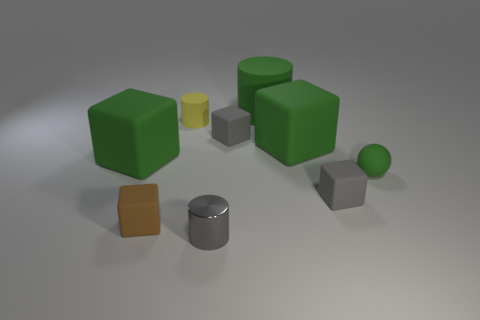Subtract all gray cubes. How many cubes are left? 3 Subtract all green blocks. How many blocks are left? 3 Add 1 rubber spheres. How many objects exist? 10 Subtract all cyan blocks. Subtract all red cylinders. How many blocks are left? 5 Subtract all cylinders. How many objects are left? 6 Add 4 small gray metal cylinders. How many small gray metal cylinders exist? 5 Subtract 0 cyan cubes. How many objects are left? 9 Subtract all small matte balls. Subtract all gray cylinders. How many objects are left? 7 Add 6 tiny gray matte cubes. How many tiny gray matte cubes are left? 8 